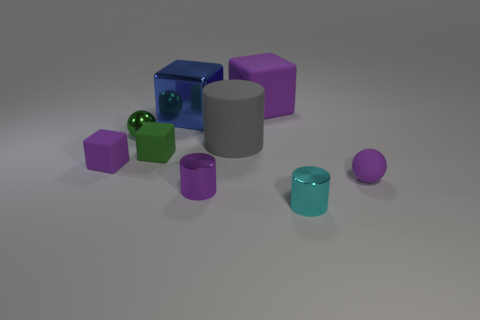Subtract 2 blocks. How many blocks are left? 2 Subtract all small green blocks. How many blocks are left? 3 Add 1 small purple rubber balls. How many objects exist? 10 Subtract all blue blocks. How many blocks are left? 3 Subtract all yellow blocks. Subtract all purple cylinders. How many blocks are left? 4 Subtract all spheres. How many objects are left? 7 Subtract all tiny cyan shiny objects. Subtract all small green cylinders. How many objects are left? 8 Add 4 big metal cubes. How many big metal cubes are left? 5 Add 6 big yellow matte cylinders. How many big yellow matte cylinders exist? 6 Subtract 0 brown balls. How many objects are left? 9 